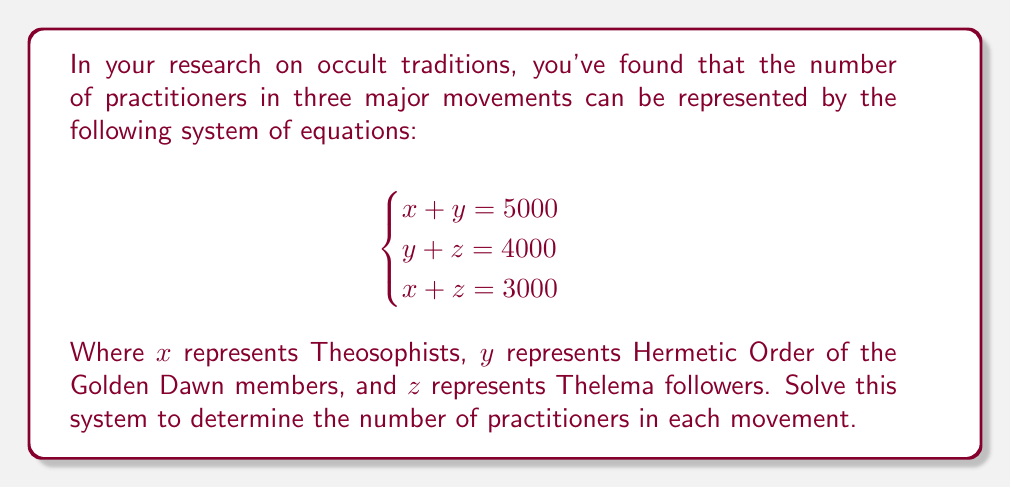Provide a solution to this math problem. To solve this system of equations, we'll use the substitution method:

1) From the first equation: $x = 5000 - y$

2) Substitute this into the third equation:
   $(5000 - y) + z = 3000$
   $5000 + z - y = 3000$
   $z - y = -2000$ ... (Equation A)

3) From the second equation:
   $z = 4000 - y$ ... (Equation B)

4) Substitute Equation B into Equation A:
   $(4000 - y) - y = -2000$
   $4000 - 2y = -2000$
   $-2y = -6000$
   $y = 3000$

5) Now that we know $y$, we can find $x$ and $z$:
   $x = 5000 - y = 5000 - 3000 = 2000$
   $z = 4000 - y = 4000 - 3000 = 1000$

Therefore:
$x = 2000$ (Theosophists)
$y = 3000$ (Golden Dawn)
$z = 1000$ (Thelema)
Answer: $x = 2000$, $y = 3000$, $z = 1000$ 